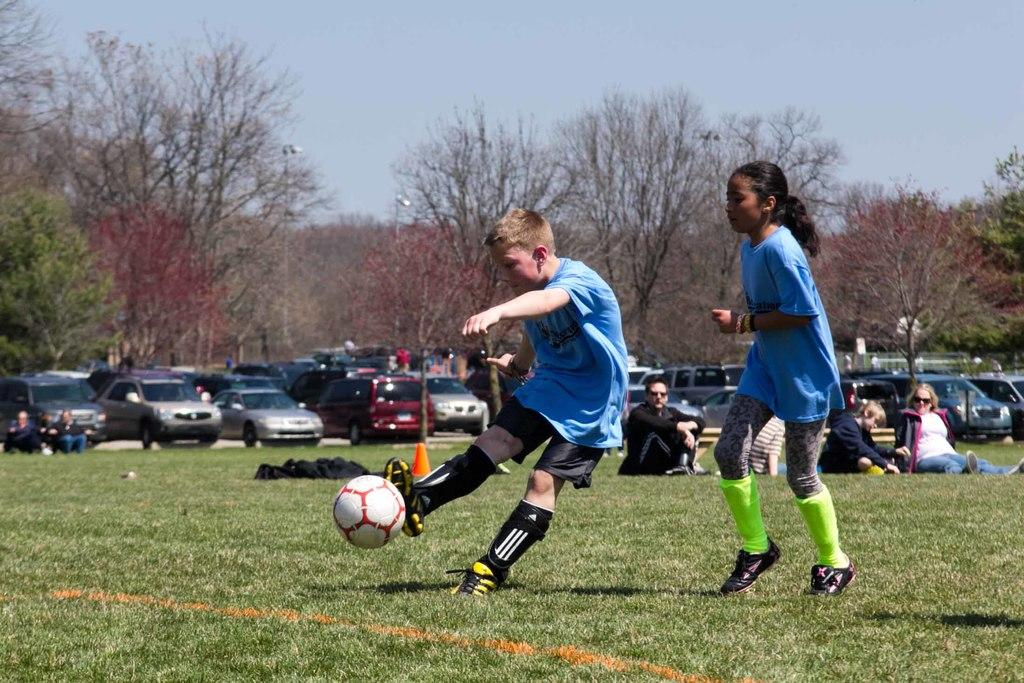What is happening in the center of the image? There are two players in the center of the image. Where is the ball located in the image? The ball is on the left side of the image. What can be seen in the background of the image? There are trees, the sky, vehicles, and people sitting on the grass in the background of the image. Can you tell me how many houses are visible in the image? There are no houses present in the image. What type of flight is taking place in the image? There is no flight present in the image; it features two players, a ball, and various background elements. 